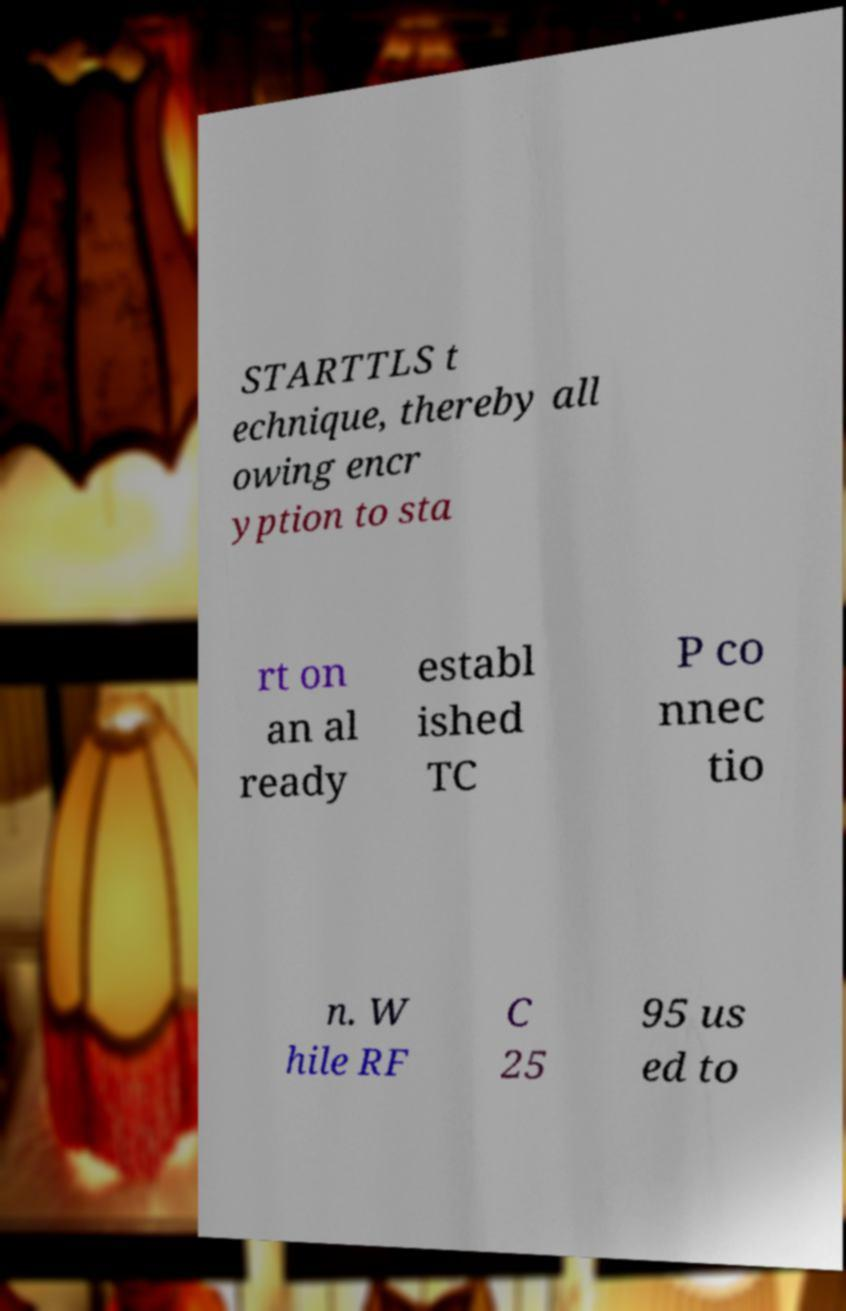Can you read and provide the text displayed in the image?This photo seems to have some interesting text. Can you extract and type it out for me? STARTTLS t echnique, thereby all owing encr yption to sta rt on an al ready establ ished TC P co nnec tio n. W hile RF C 25 95 us ed to 